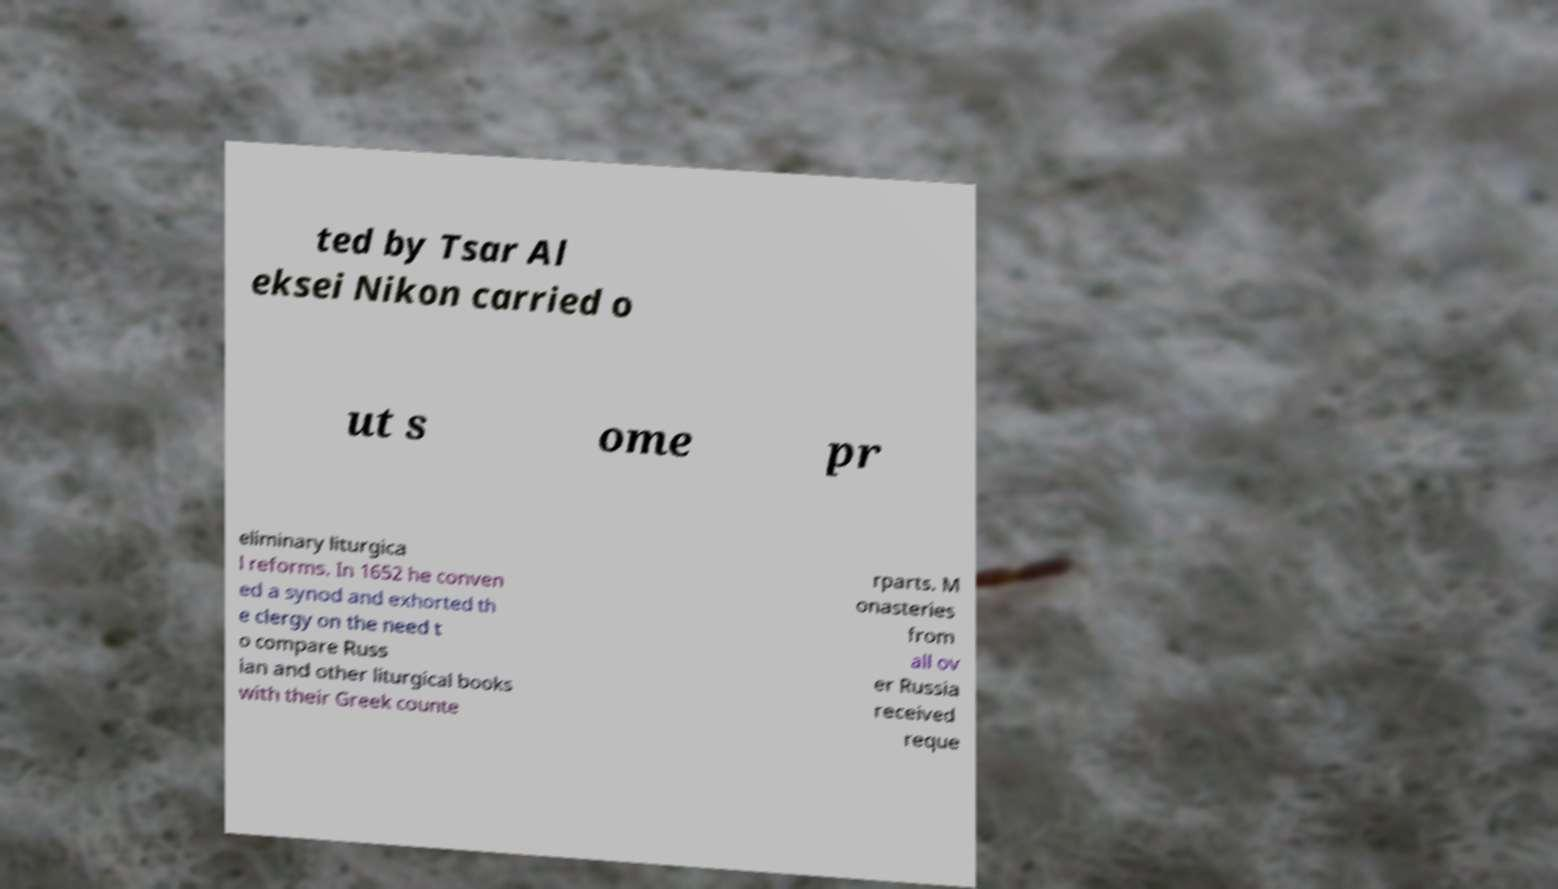I need the written content from this picture converted into text. Can you do that? ted by Tsar Al eksei Nikon carried o ut s ome pr eliminary liturgica l reforms. In 1652 he conven ed a synod and exhorted th e clergy on the need t o compare Russ ian and other liturgical books with their Greek counte rparts. M onasteries from all ov er Russia received reque 